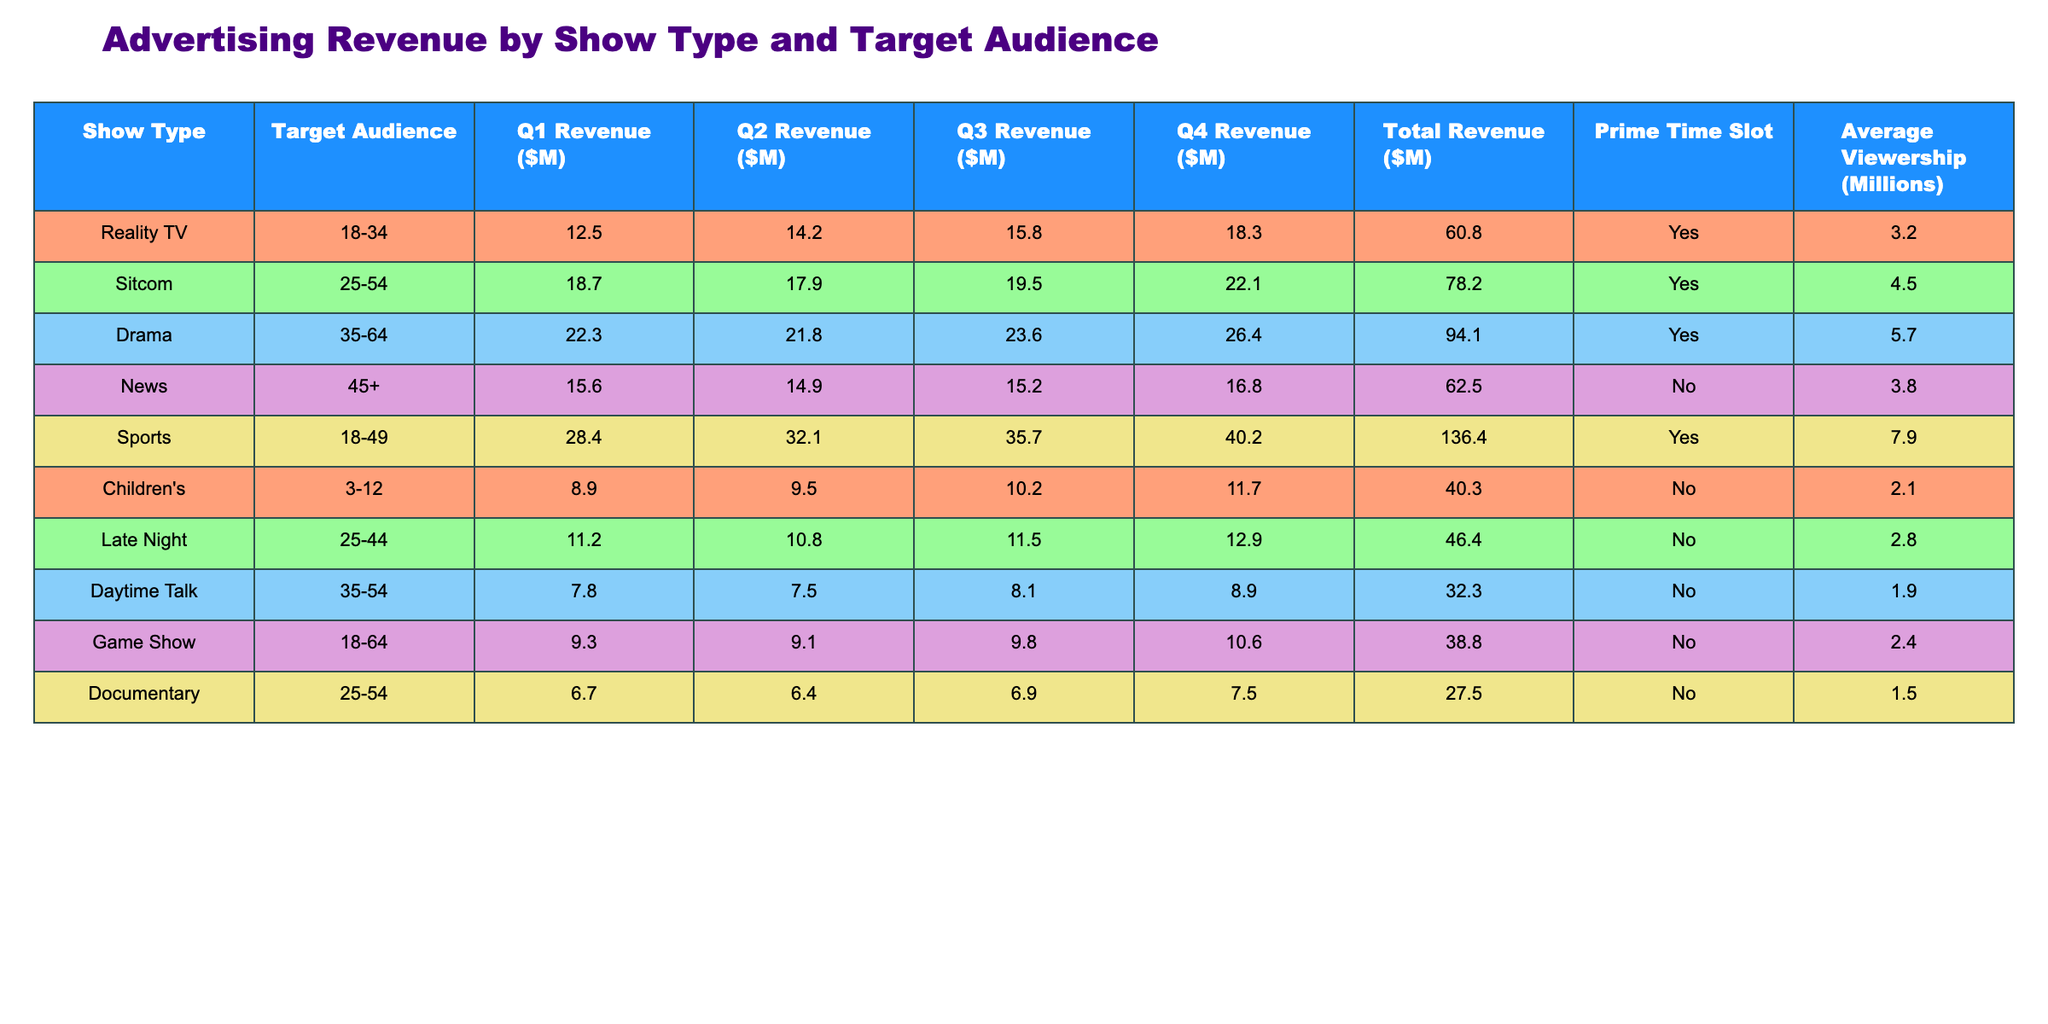What is the total revenue for Reality TV? By looking at the "Total Revenue ($M)" column under Reality TV, the total revenue is listed as 60.8 million dollars.
Answer: 60.8 million Which show type has the highest average viewership? The average viewership is listed for each show type; Sports has the highest at 7.9 million.
Answer: Sports What was the Q4 revenue for Dramas? The Q4 column under the Drama row shows a revenue of 26.4 million dollars.
Answer: 26.4 million Is the Sitcom targeted at the 25-54 audience during prime time? The "Prime Time Slot" column for Sitcom shows "Yes", indicating it is indeed during prime time.
Answer: Yes What is the average revenue across all shows for Q1? To find the average for Q1, sum the Q1 revenues: (12.5 + 18.7 + 22.3 + 15.6 + 28.4 + 8.9 + 11.2 + 7.8 + 9.3 + 6.7) = 139.4 million. There are 10 shows, so the average is 139.4 / 10 = 13.94 million.
Answer: 13.94 million What is the total revenue for the Children's show? From the "Total Revenue ($M)" column, the revenue for the Children's show is 40.3 million dollars.
Answer: 40.3 million Which show type has the lowest total revenue? The total revenues for each show type show that Documentary has the lowest total revenue of 27.5 million.
Answer: Documentary What was the total revenue difference between News and Sports? The total revenue for News is 62.5 million, and for Sports, it is 136.4 million. The difference is 136.4 - 62.5 = 73.9 million.
Answer: 73.9 million For which show types is the average viewership below 3 million? The average viewership for Daytime Talk (1.9 million), Documentary (1.5 million), and Children’s (2.1 million) are all below 3 million.
Answer: Daytime Talk, Documentary, Children's What is the percentage of total revenue generated by Sports compared to the total revenues of all shows combined? The total revenue from all shows is 440.0 million (60.8 + 78.2 + 94.1 + 62.5 + 136.4 + 40.3 + 46.4 + 32.3 + 38.8 + 27.5). For Sports, 136.4 million is generated. The percentage is (136.4 / 440.0) * 100 = approximately 31.0%.
Answer: 31.0% 